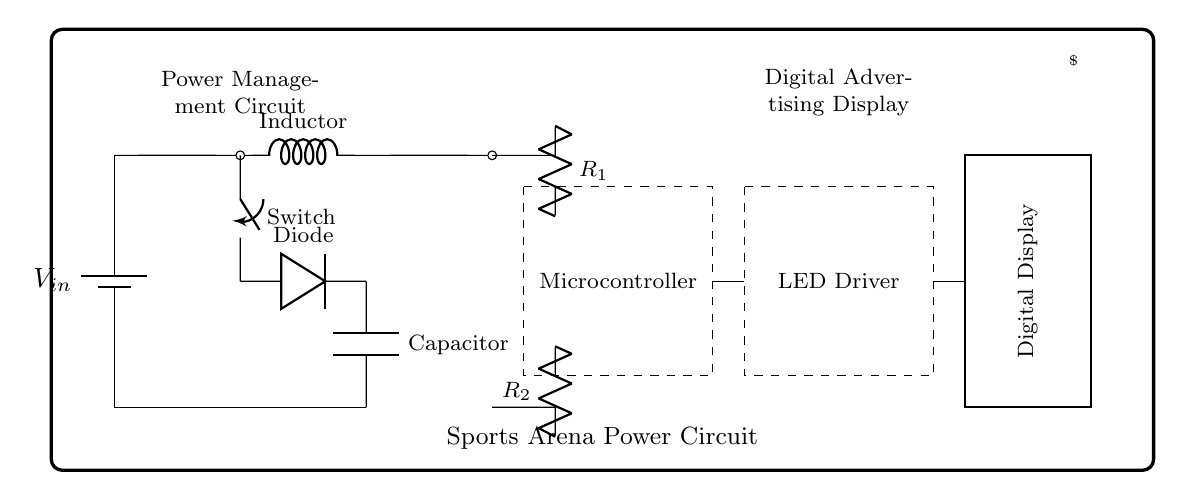What is the input voltage of this circuit? The input voltage is represented by the symbol V_in, which indicates the voltage supplied to the circuit.
Answer: V_in What component acts as the energy storage device? The capacitor in the circuit is responsible for storing energy; it is labeled as such, indicating its role in smoothing the output voltage.
Answer: Capacitor How many resistors are present in the circuit? There are two resistors denoted as R_1 and R_2, which can be identified by looking for the symbols labeled with these designations.
Answer: 2 What does the microcontroller in the circuit control? The microcontroller is the component responsible for managing and controlling the power distribution to the LED driver, which is indicated by its connection in the diagram.
Answer: LED Driver What type of converter is shown in this circuit? The circuit includes a buck converter, which is indicated by the arrangement of components including an inductor, switch, and diode all working together to step-down voltage.
Answer: Buck Converter What is the purpose of the diode in this circuit? The diode allows current to flow in one direction only, thus preventing potential reverse current that could damage circuit components; this is essential for the functionality of the buck converter.
Answer: Prevent reverse current What is the main application of this power management circuit? The primary application is to manage power supplied to digital advertising displays, as indicated by the label "Digital Display" and its connection to the power management system.
Answer: Digital Advertising Displays 